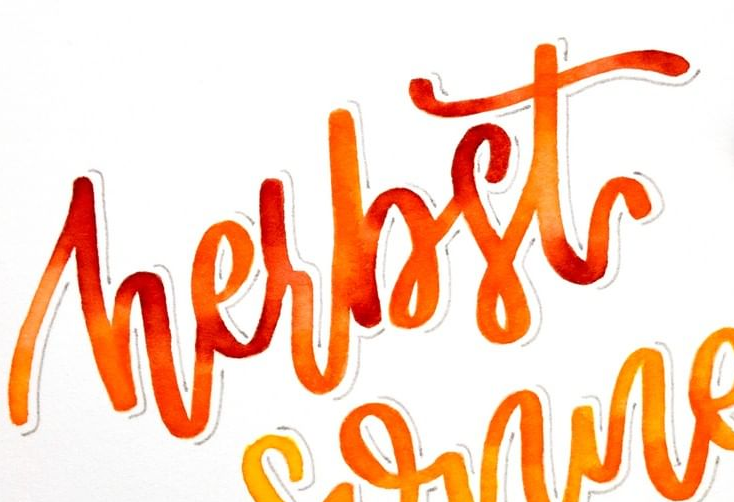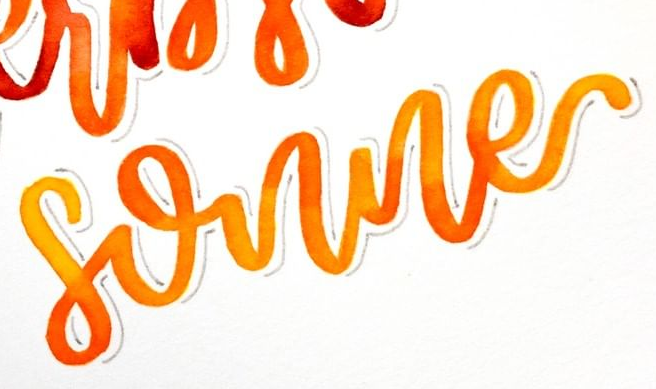What text is displayed in these images sequentially, separated by a semicolon? hesbst; sonne 